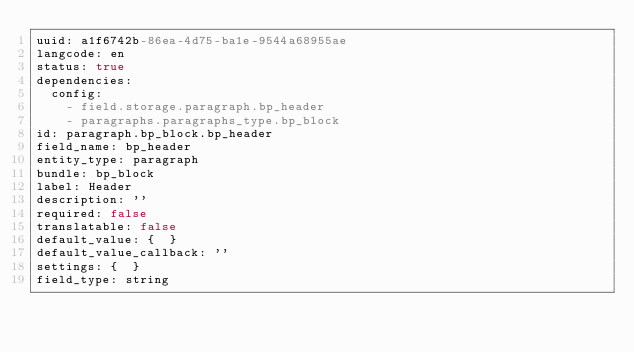Convert code to text. <code><loc_0><loc_0><loc_500><loc_500><_YAML_>uuid: a1f6742b-86ea-4d75-ba1e-9544a68955ae
langcode: en
status: true
dependencies:
  config:
    - field.storage.paragraph.bp_header
    - paragraphs.paragraphs_type.bp_block
id: paragraph.bp_block.bp_header
field_name: bp_header
entity_type: paragraph
bundle: bp_block
label: Header
description: ''
required: false
translatable: false
default_value: {  }
default_value_callback: ''
settings: {  }
field_type: string
</code> 